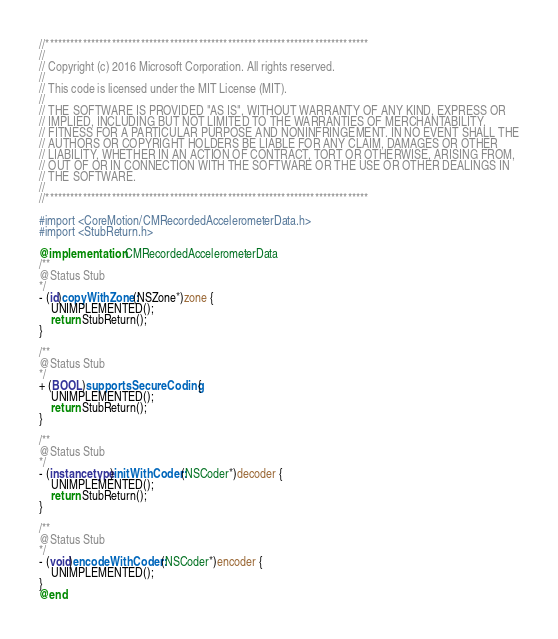<code> <loc_0><loc_0><loc_500><loc_500><_ObjectiveC_>//******************************************************************************
//
// Copyright (c) 2016 Microsoft Corporation. All rights reserved.
//
// This code is licensed under the MIT License (MIT).
//
// THE SOFTWARE IS PROVIDED "AS IS", WITHOUT WARRANTY OF ANY KIND, EXPRESS OR
// IMPLIED, INCLUDING BUT NOT LIMITED TO THE WARRANTIES OF MERCHANTABILITY,
// FITNESS FOR A PARTICULAR PURPOSE AND NONINFRINGEMENT. IN NO EVENT SHALL THE
// AUTHORS OR COPYRIGHT HOLDERS BE LIABLE FOR ANY CLAIM, DAMAGES OR OTHER
// LIABILITY, WHETHER IN AN ACTION OF CONTRACT, TORT OR OTHERWISE, ARISING FROM,
// OUT OF OR IN CONNECTION WITH THE SOFTWARE OR THE USE OR OTHER DEALINGS IN
// THE SOFTWARE.
//
//******************************************************************************

#import <CoreMotion/CMRecordedAccelerometerData.h>
#import <StubReturn.h>

@implementation CMRecordedAccelerometerData
/**
@Status Stub
*/
- (id)copyWithZone:(NSZone*)zone {
    UNIMPLEMENTED();
    return StubReturn();
}

/**
@Status Stub
*/
+ (BOOL)supportsSecureCoding {
    UNIMPLEMENTED();
    return StubReturn();
}

/**
@Status Stub
*/
- (instancetype)initWithCoder:(NSCoder*)decoder {
    UNIMPLEMENTED();
    return StubReturn();
}

/**
@Status Stub
*/
- (void)encodeWithCoder:(NSCoder*)encoder {
    UNIMPLEMENTED();
}
@end
</code> 